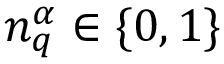Convert formula to latex. <formula><loc_0><loc_0><loc_500><loc_500>{ n } _ { q } ^ { \alpha } \in \{ 0 , 1 \}</formula> 